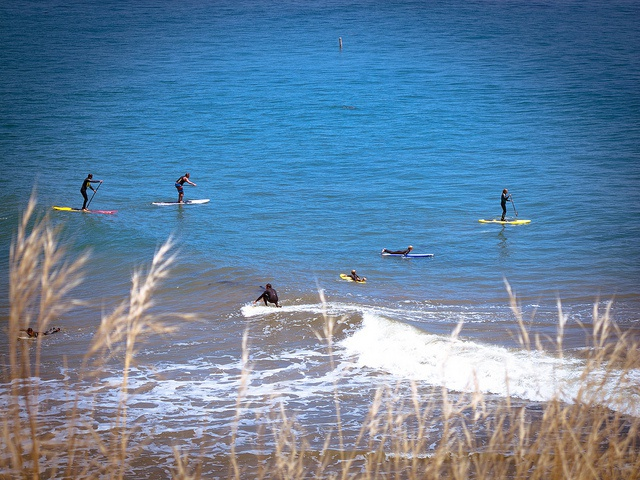Describe the objects in this image and their specific colors. I can see surfboard in darkblue, white, darkgray, and lightgray tones, surfboard in darkblue, white, and gray tones, people in darkblue, black, gray, maroon, and purple tones, surfboard in darkblue, gray, khaki, beige, and darkgray tones, and people in darkblue, black, maroon, lightblue, and navy tones in this image. 